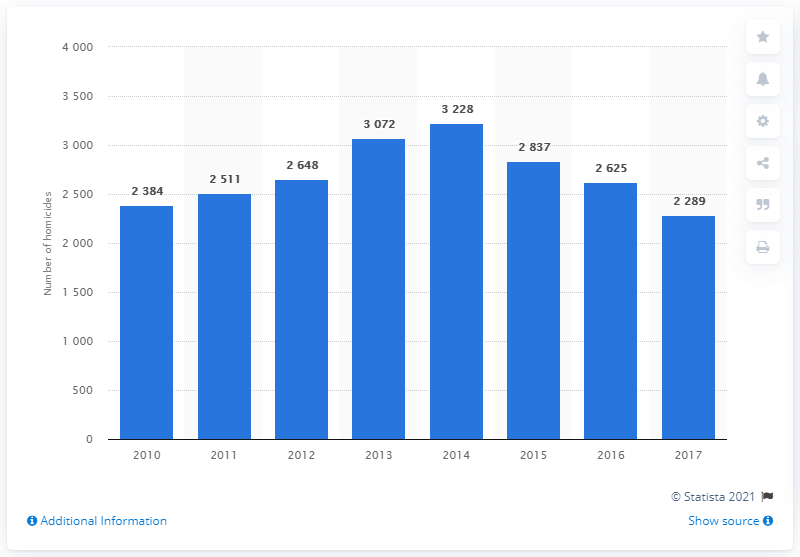List a handful of essential elements in this visual. In 2014, the deadliest year in terms of the number of homicides, Since 2014, the number of victims of intentional homicide in Argentina has been decreasing. 